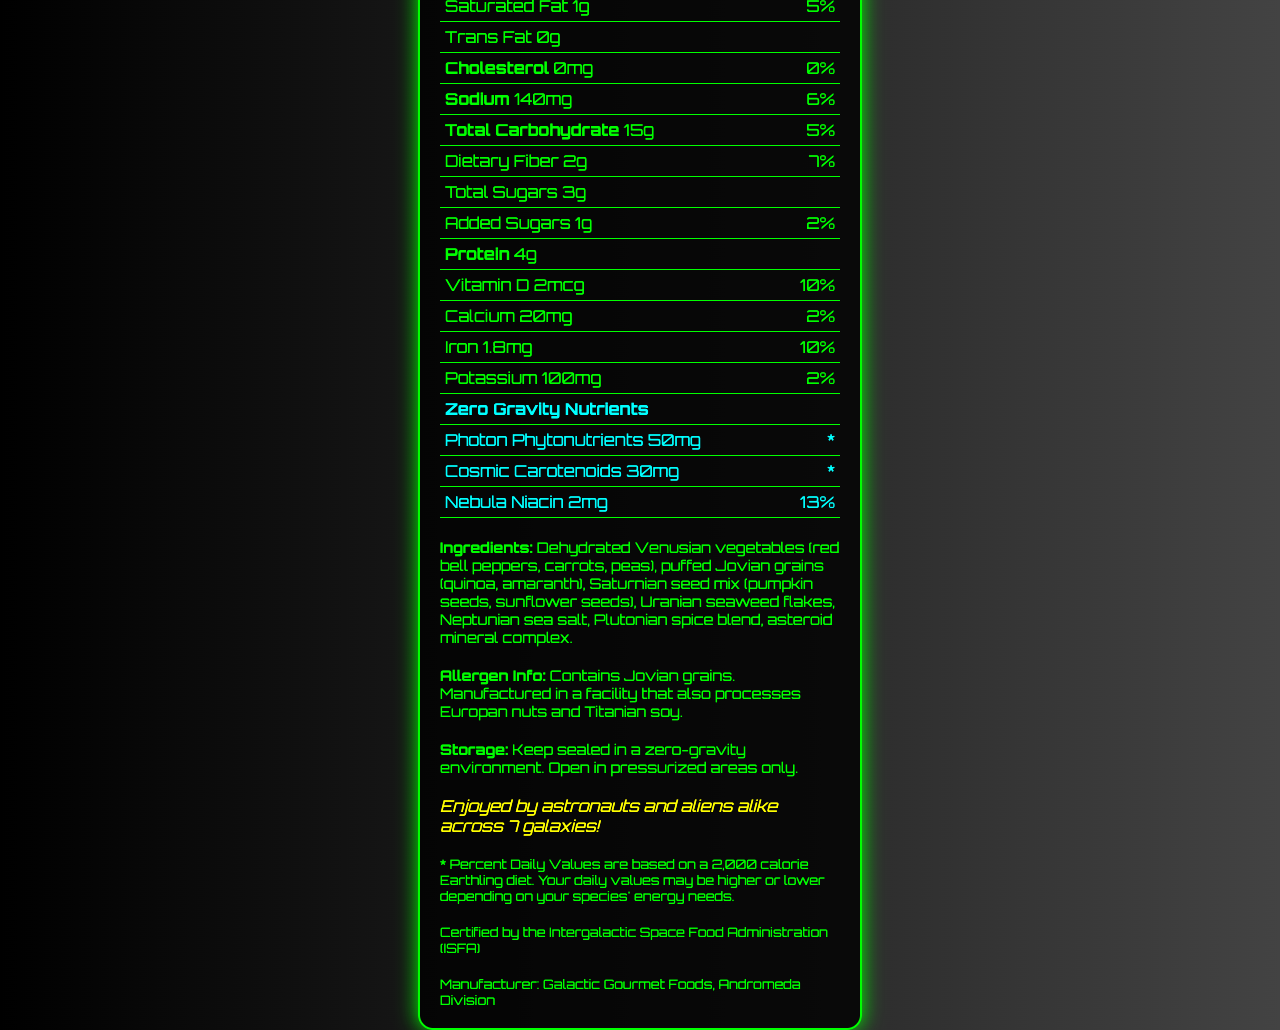what is the serving size for Martian Munchies Zero-G Snack Mix? The serving size is listed near the top of the document under the "Nutrition Facts" heading.
Answer: 1 antigravity pouch (30g) how many calories are in one serving? The number of calories per serving is displayed in bold under the list of servings per container.
Answer: 120 how much sodium is in a serving? Sodium content is found under the nutrients listed in the document.
Answer: 140mg what are the two zero-gravity nutrients mentioned in the document? These are listed in the Zero Gravity Nutrients section of the table.
Answer: Photon Phytonutrients and Cosmic Carotenoids what is the daily value percentage for Nebula Niacin? The daily value of Nebula Niacin is mentioned in the Zero Gravity Nutrients section.
Answer: 13% which planet's seaweed flakes are included in the ingredients? A. Venus B. Earth C. Uranus D. Mars Uranian seaweed flakes are listed in the ingredients section.
Answer: C. Uranus how many servings per container does Martian Munchies have? Servings per container are listed near the top of the document, just below the serving size.
Answer: 10 which of the following is not a listed ingredient? A. Puffed Jovian grains B. Saturnian seed mix C. Martian marshmallows D. Neptunian sea salt Martian marshmallows are not listed among the ingredients.
Answer: C. Martian marshmallows is the product certified by the Intergalactic Space Food Administration (ISFA)? This certification is mentioned at the bottom of the document.
Answer: Yes summarize the entire document The document contains detailed nutritional information for a space-themed snack mix, including both standard and unique nutrients, along with additional product details and certifications.
Answer: The document is a Nutrition Facts label for Martian Munchies Zero-G Snack Mix. It provides information on the serving size, calories, and various nutrients per serving. It also lists zero-gravity nutrients specific to the product, ingredients, allergen information, storage instructions, a fun fact, and a disclaimer about daily values based on a 2,000 calorie diet. The product is certified by the Intergalactic Space Food Administration (ISFA) and is manufactured by Galactic Gourmet Foods. how much Vitamin D is in a serving? The amount of Vitamin D per serving is listed in the table of nutrients.
Answer: 2mcg does this product contain any trans fat? The document states that Trans Fat is 0g per serving.
Answer: No in which environments should the Martian Munchies be kept sealed? The storage instructions specify keeping the product sealed in a zero-gravity environment.
Answer: Zero-gravity environment does this product include any allergens? The allergen information notes that the product contains Jovian grains and is produced in a facility that processes Europan nuts and Titanian soy.
Answer: Yes who is the manufacturer of Martian Munchies? The manufacturer is listed at the bottom of the document.
Answer: Galactic Gourmet Foods, Andromeda Division what is the daily value percentage of dietary fiber in the snack mix? The daily value percentage for dietary fiber is listed in the nutrients table.
Answer: 7% does the document specify the exact nutritional needs of aliens? The document only provides a disclaimer that daily values are based on a 2,000 calorie Earthling diet and may vary based on the species' energy needs, but it does not specify exact nutritional needs for aliens.
Answer: No 